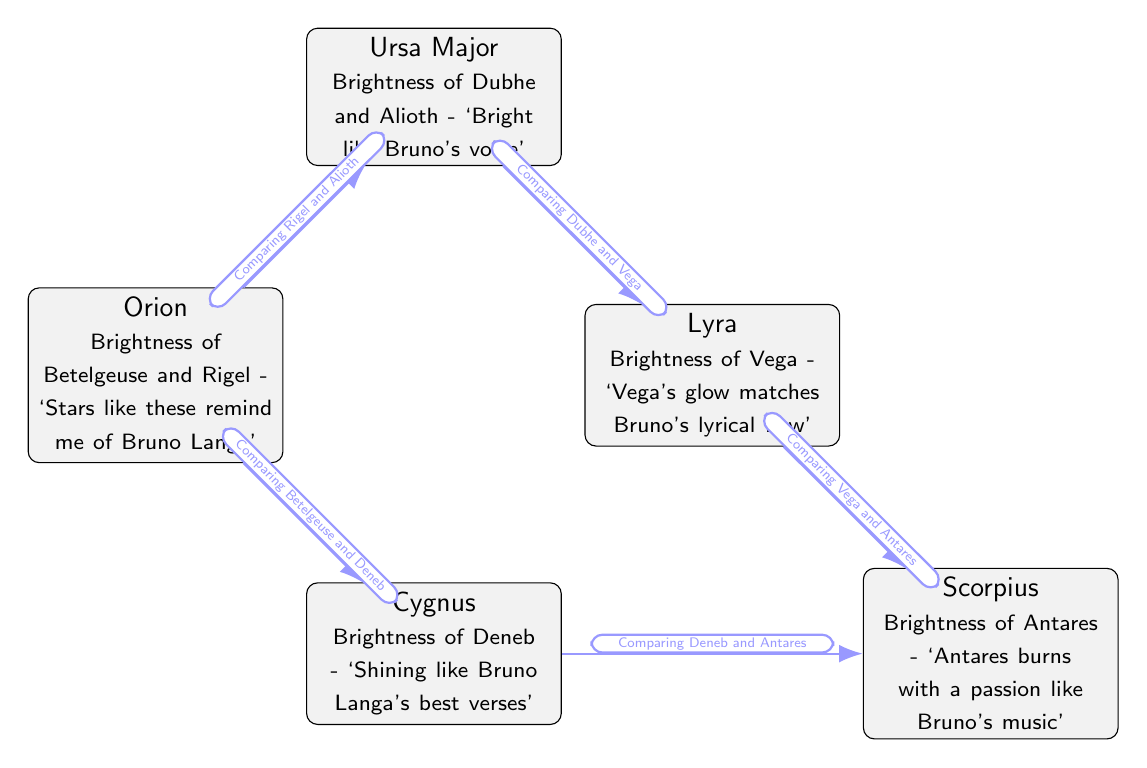What are the two stars compared in the node labeled "Orion"? The node labeled "Orion" compares the brightness of Betelgeuse and Rigel.
Answer: Betelgeuse and Rigel Which constellation features the comparison between Dubhe and Vega? The node labeled "Ursa Major" shows the comparison of brightness between Dubhe and Vega.
Answer: Ursa Major What is the brightness of the star denoted in the node for "Cygnus"? The node for "Cygnus" mentions the brightness of Deneb, which is directly stated in the node.
Answer: Deneb How many constellations are represented in the diagram? There are five constellations represented in the diagram: Orion, Ursa Major, Cygnus, Lyra, and Scorpius.
Answer: Five Which star's brightness comparison includes Antares? The comparisons that involve Antares are found in the nodes "Scorpius," which compares both Antares with Deneb and Vega.
Answer: Scorpius What is the descriptive label for the node representing "Lyra"? The node for "Lyra" describes the brightness of Vega with the lyrical flow of Bruno Langa as the associated music lyric inspiration.
Answer: Brightness of Vega - ‘Vega's glow matches Bruno's lyrical flow’ What constellations are compared with Orion in the diagram? The constellations compared with Orion in the diagram are Ursa Major and Cygnus, as reflected in the edges leading from Orion.
Answer: Ursa Major and Cygnus Which constellation's node contains a comparison related to Bruno's passion? The Scorpius node contains the comparison related to Bruno's passion, particularly mentioning Antares's brightness.
Answer: Scorpius In total, how many edges are there connecting the different star brightness comparisons? The diagram has four edges connecting different star brightness comparisons between the constellations.
Answer: Four 